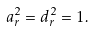<formula> <loc_0><loc_0><loc_500><loc_500>a _ { r } ^ { 2 } = d _ { r } ^ { 2 } = 1 .</formula> 